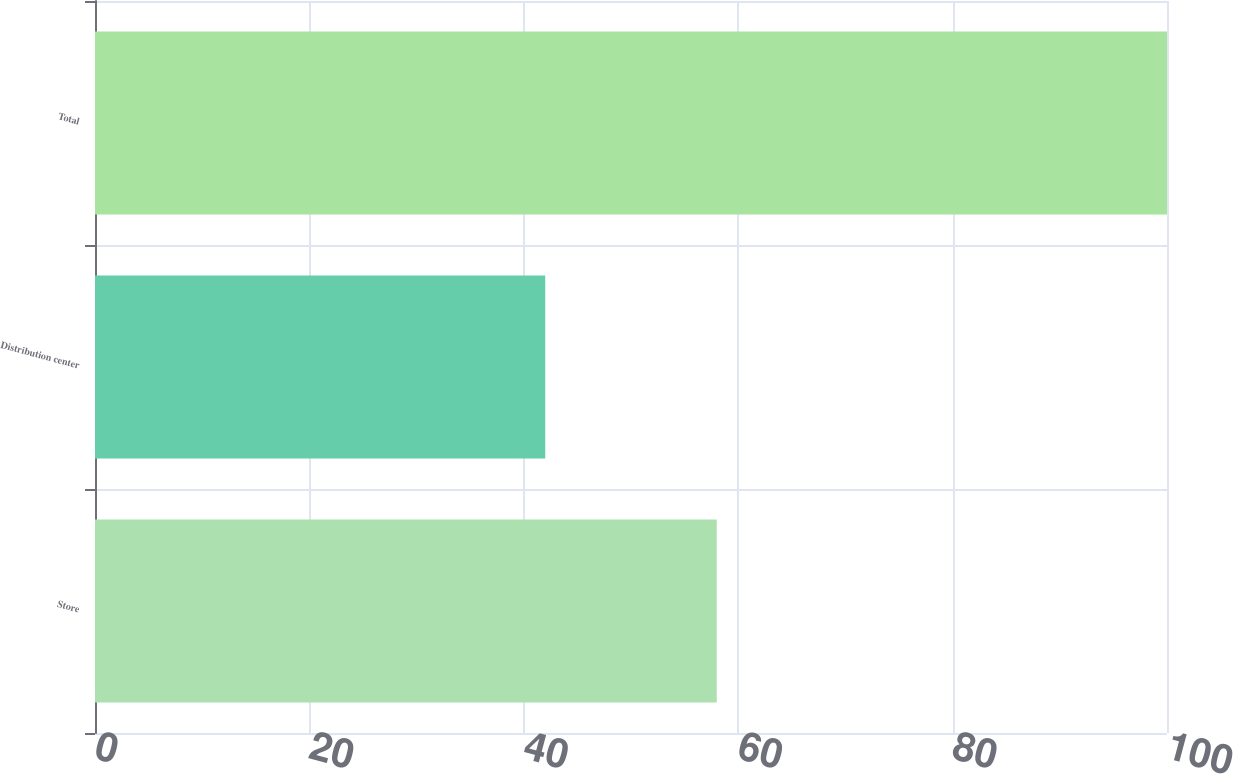Convert chart to OTSL. <chart><loc_0><loc_0><loc_500><loc_500><bar_chart><fcel>Store<fcel>Distribution center<fcel>Total<nl><fcel>58<fcel>42<fcel>100<nl></chart> 